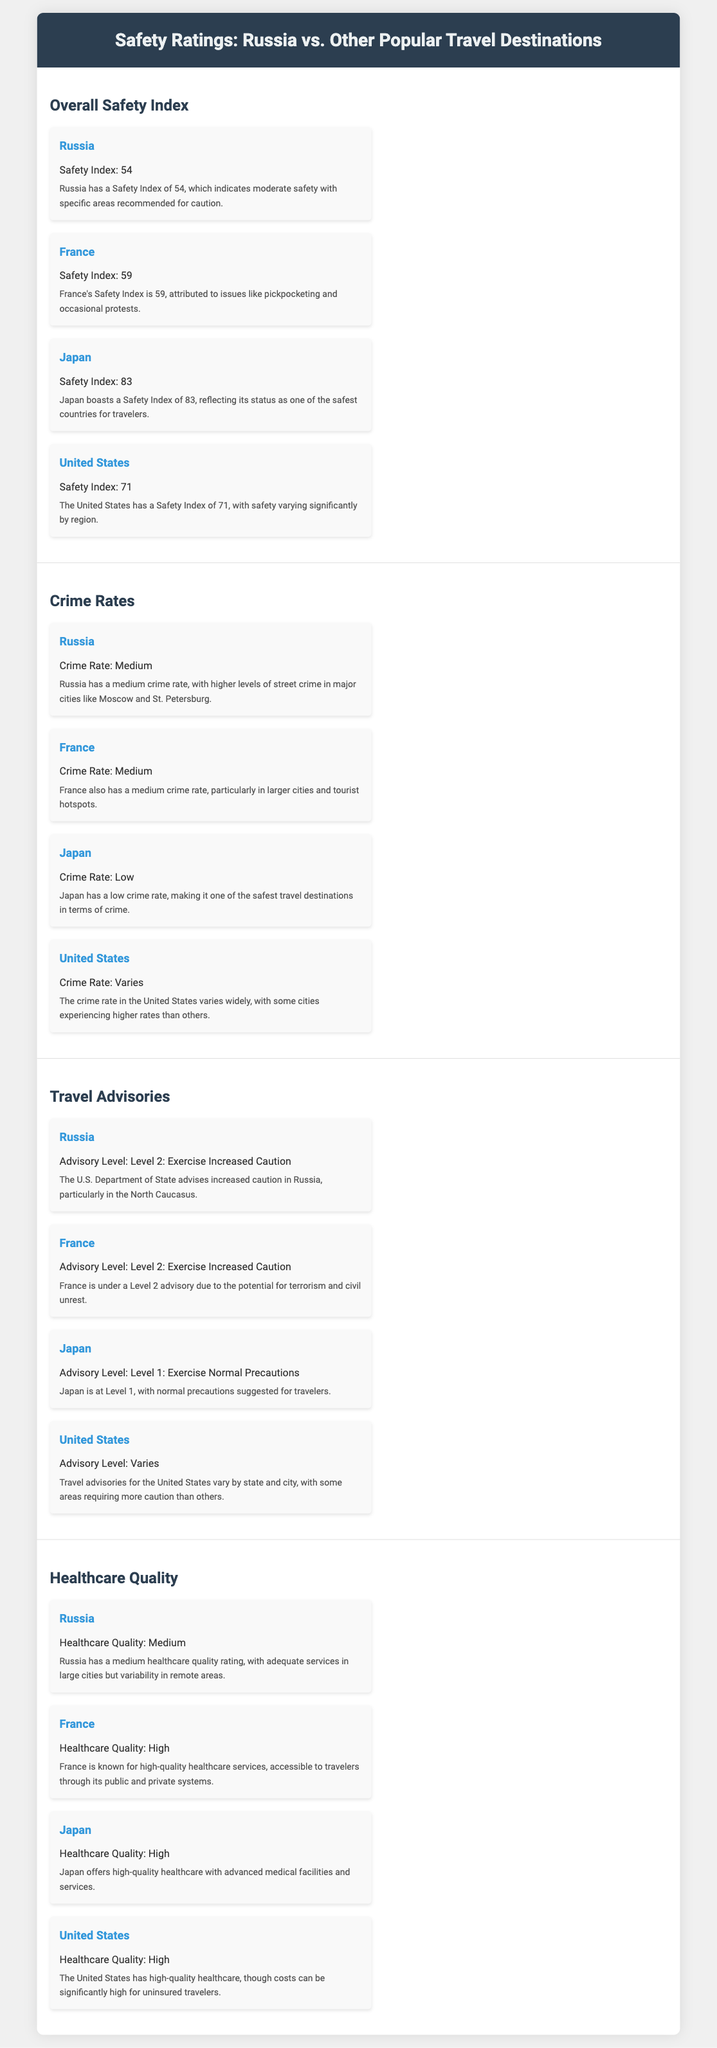What is Russia's Safety Index? Russia's Safety Index is provided in the infographic, indicating its safety level compared to other countries.
Answer: 54 What is Japan's Crime Rate? The document states that Japan has a low crime rate, which is provided as a comparison to other countries.
Answer: Low What level of travel advisory is given for France? The travel advisory levels for each country can be found in the infographic, and France's level is mentioned.
Answer: Level 2: Exercise Increased Caution Which country has the highest healthcare quality rating? The healthcare quality ratings for all countries are compared in the infographic, indicating which have high ratings.
Answer: France and Japan What specific caution is advised for travelers in Russia? The description for Russia includes specific advice regarding areas that travelers should be cautious about.
Answer: Increased Caution in North Caucasus Which country is reported to have a medium crime rate similar to Russia? The document shows a comparison of crime rates among various countries, including Russia.
Answer: France What Safety Index number does the United States have? The United States' Safety Index is mentioned in the section comparing overall safety indices.
Answer: 71 What type of healthcare quality does Russia have? The infographic provides a comparative quality rating for healthcare across countries.
Answer: Medium 